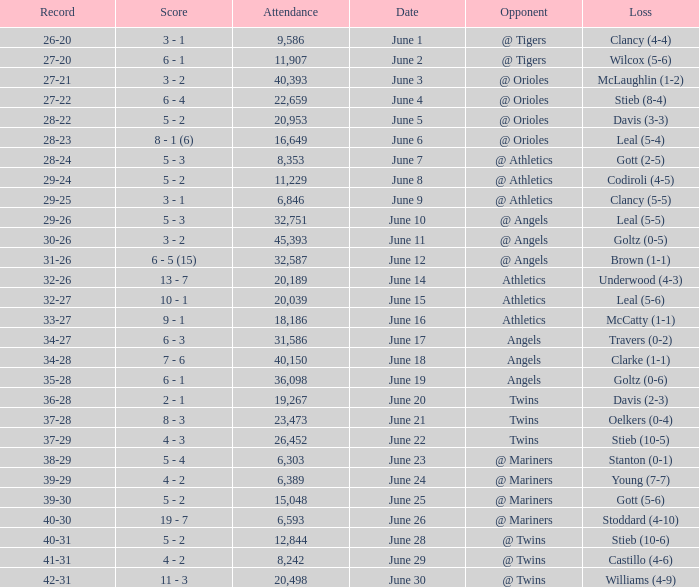What was the record for the date of June 14? 32-26. 